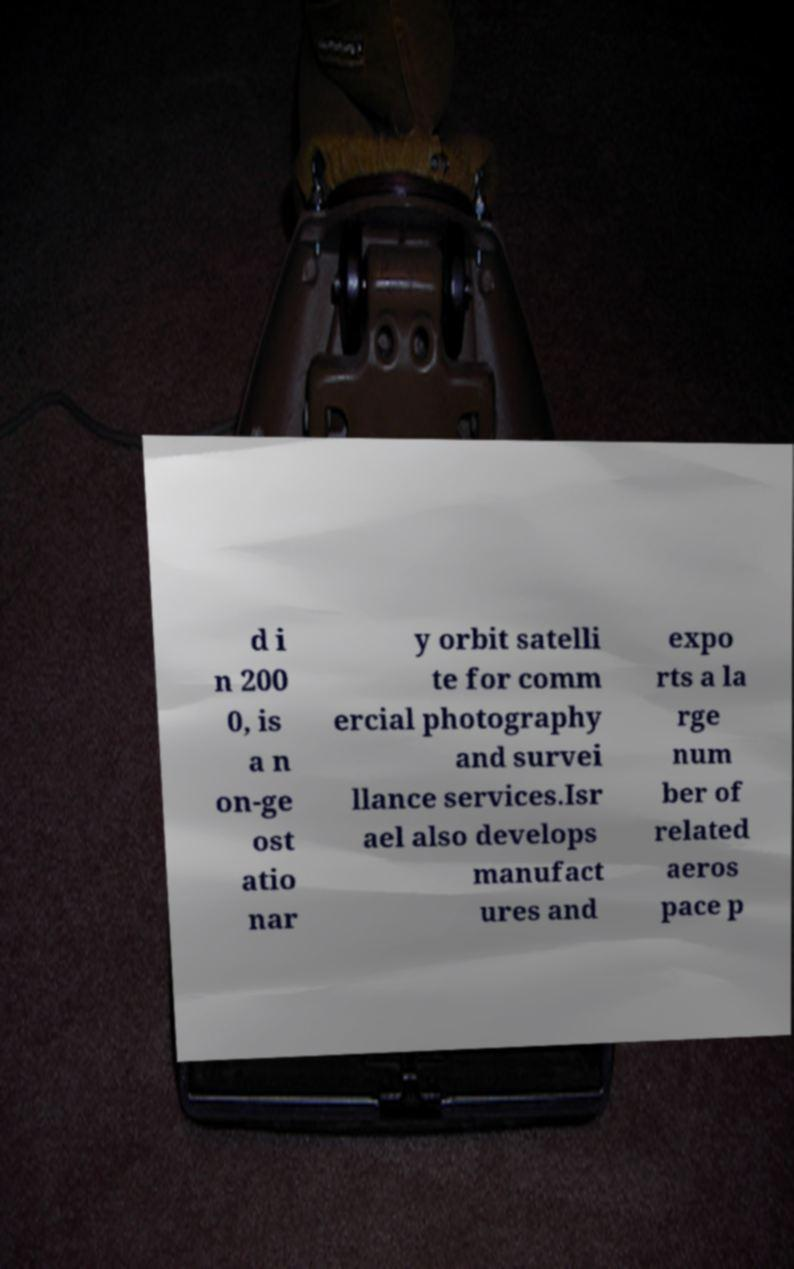I need the written content from this picture converted into text. Can you do that? d i n 200 0, is a n on-ge ost atio nar y orbit satelli te for comm ercial photography and survei llance services.Isr ael also develops manufact ures and expo rts a la rge num ber of related aeros pace p 